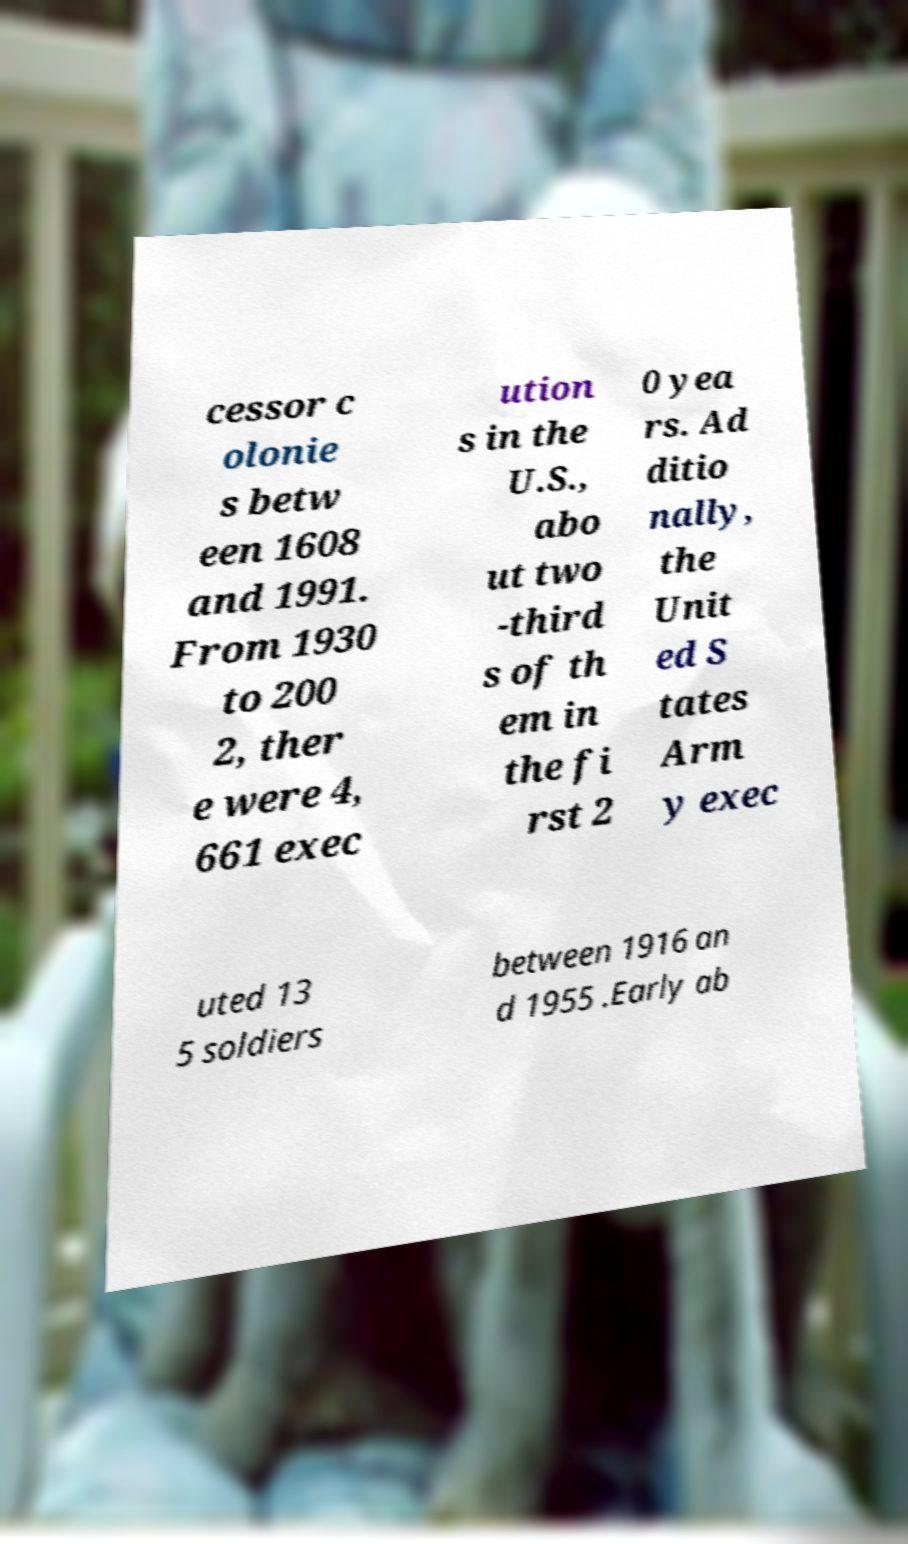Could you assist in decoding the text presented in this image and type it out clearly? cessor c olonie s betw een 1608 and 1991. From 1930 to 200 2, ther e were 4, 661 exec ution s in the U.S., abo ut two -third s of th em in the fi rst 2 0 yea rs. Ad ditio nally, the Unit ed S tates Arm y exec uted 13 5 soldiers between 1916 an d 1955 .Early ab 